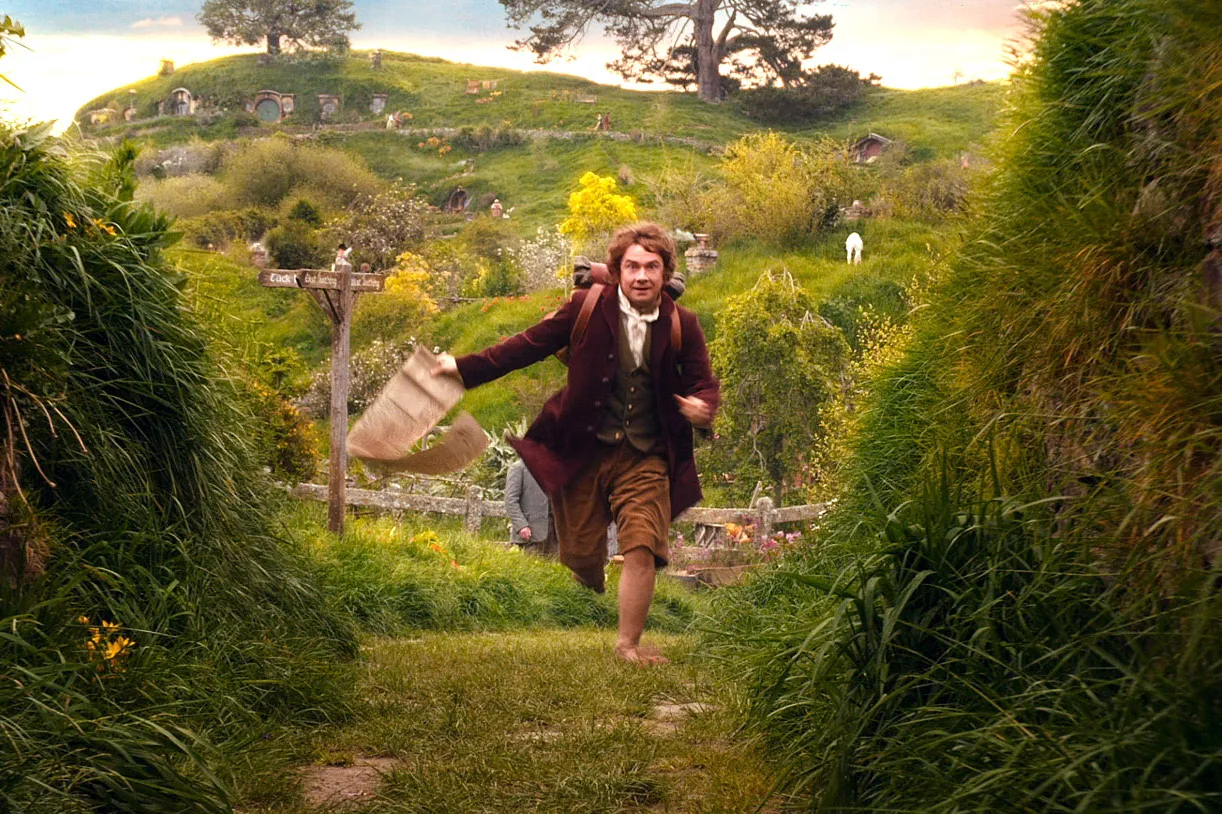How does the setting contribute to the narrative depicted in the image? The lush, vividly green landscape filled with well-maintained gardens and unique hillside homes deeply enhances the narrative by emphasizing the tranquil and idyllic nature of the Shire. This contrasts dramatically with the urgency shown by the character's actions, adding a layer of complexity to the scene, suggesting a disruption in the peaceful life of Hobbiton. Is there any significance to the character's expression and body language? Yes, his wide-eyed expression and dynamic posture, with arms flailing and a bag seemingly hastily grabbed, convey a sense of sudden urgency or surprise. This hints at an unexpected journey or a swift departure from routine, possibly kicking off an adventure or fleeing from an unseen threat. 